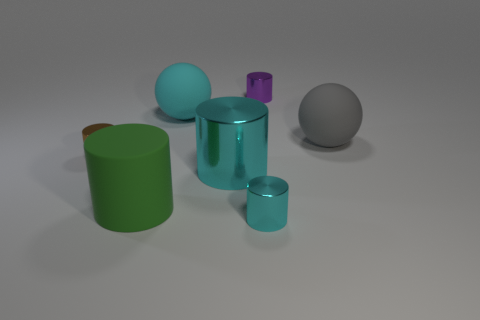What shape is the tiny metallic thing behind the shiny thing on the left side of the big thing that is on the left side of the cyan rubber ball?
Offer a terse response. Cylinder. What number of other objects are the same color as the big shiny thing?
Your response must be concise. 2. Is the number of metal objects that are left of the small cyan cylinder greater than the number of matte cylinders behind the large green cylinder?
Give a very brief answer. Yes. Are there any small things right of the big gray sphere?
Give a very brief answer. No. There is a object that is behind the big gray object and in front of the tiny purple cylinder; what is its material?
Offer a very short reply. Rubber. What color is the other matte object that is the same shape as the purple object?
Your answer should be compact. Green. Is there a big thing behind the rubber sphere that is right of the purple shiny thing?
Provide a succinct answer. Yes. How big is the purple shiny cylinder?
Keep it short and to the point. Small. The big object that is to the left of the small purple cylinder and behind the tiny brown metal thing has what shape?
Give a very brief answer. Sphere. What number of purple things are either metallic objects or large shiny things?
Offer a very short reply. 1. 